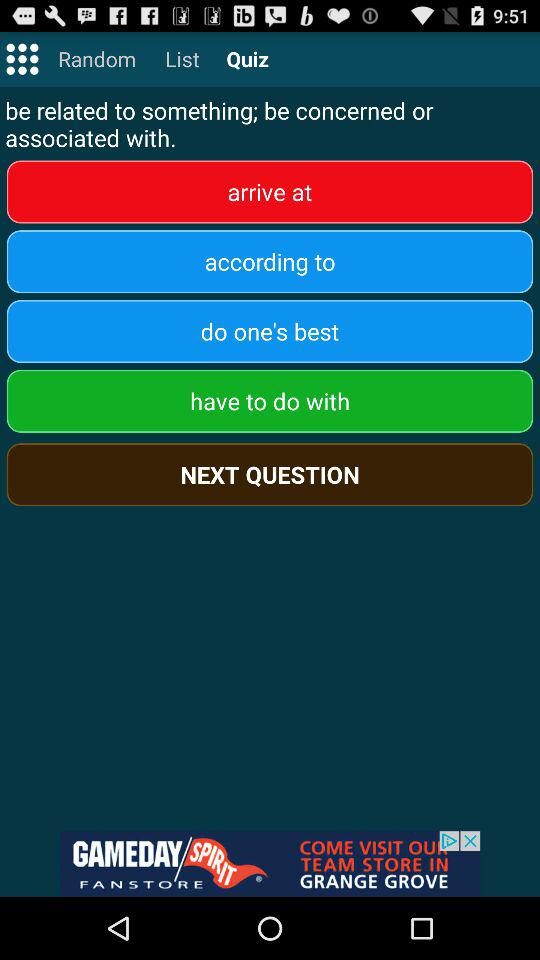Which tab am I using? You are using the "Quiz" tab. 